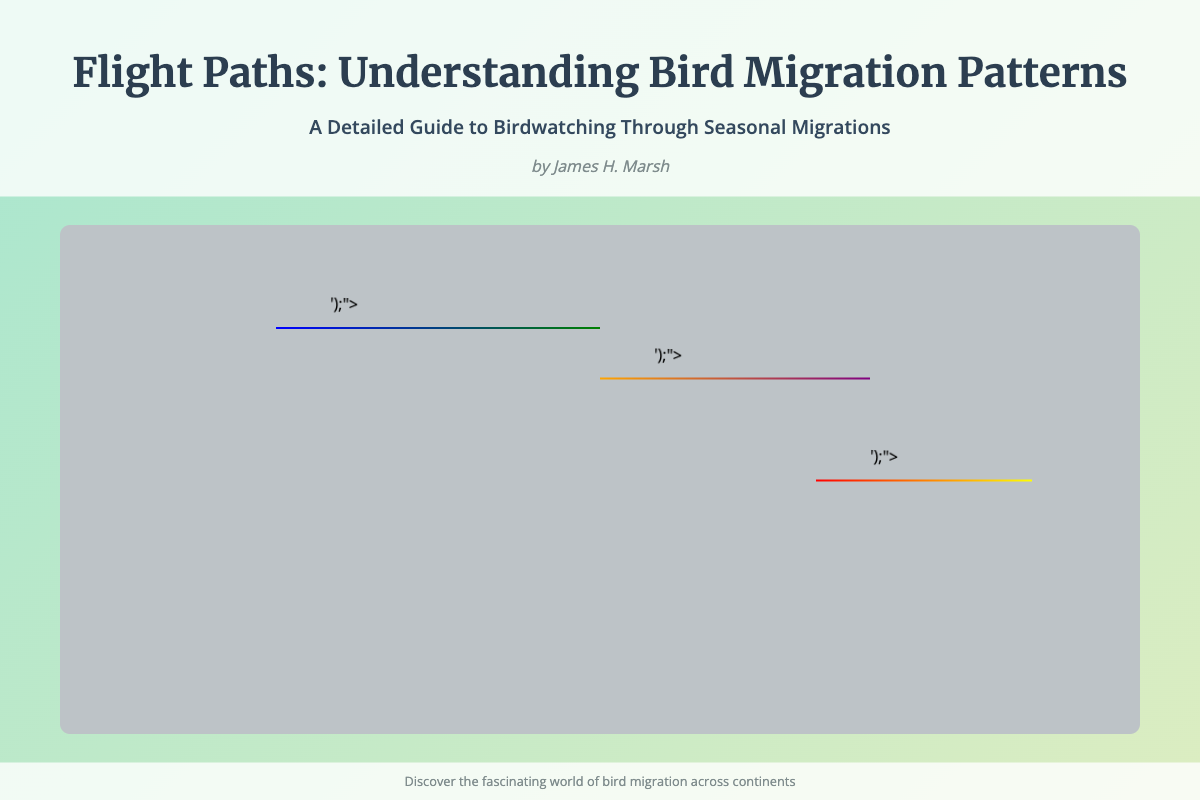What is the title of the book? The title is prominently displayed at the top of the cover in a large font.
Answer: Flight Paths: Understanding Bird Migration Patterns Who is the author of the book? The author's name is located just below the title and subtitle.
Answer: James H. Marsh What do the colorful arrows in the map represent? The arrows indicate seasonal changes in bird migration.
Answer: Seasonal changes How many migration routes are illustrated in the document? There are three migration routes depicted in different geographical areas.
Answer: Three What colors represent the North America migration route? The North America route uses a gradient of blue and green.
Answer: Blue and green What is one significant aspect of the book mentioned in the subtitle? The subtitle indicates that it is a guide to birdwatching.
Answer: Guide to birdwatching What is the background color of the book cover? The background features a gradient, combining two specific colors.
Answer: Light green and light yellow What is the theme of the book cover? The theme focuses on bird migration patterns and their understanding.
Answer: Bird migration patterns What does the footer encourage readers to do? The footer invites readers to explore the fascinating world presented in the book.
Answer: Discover the fascinating world of bird migration 